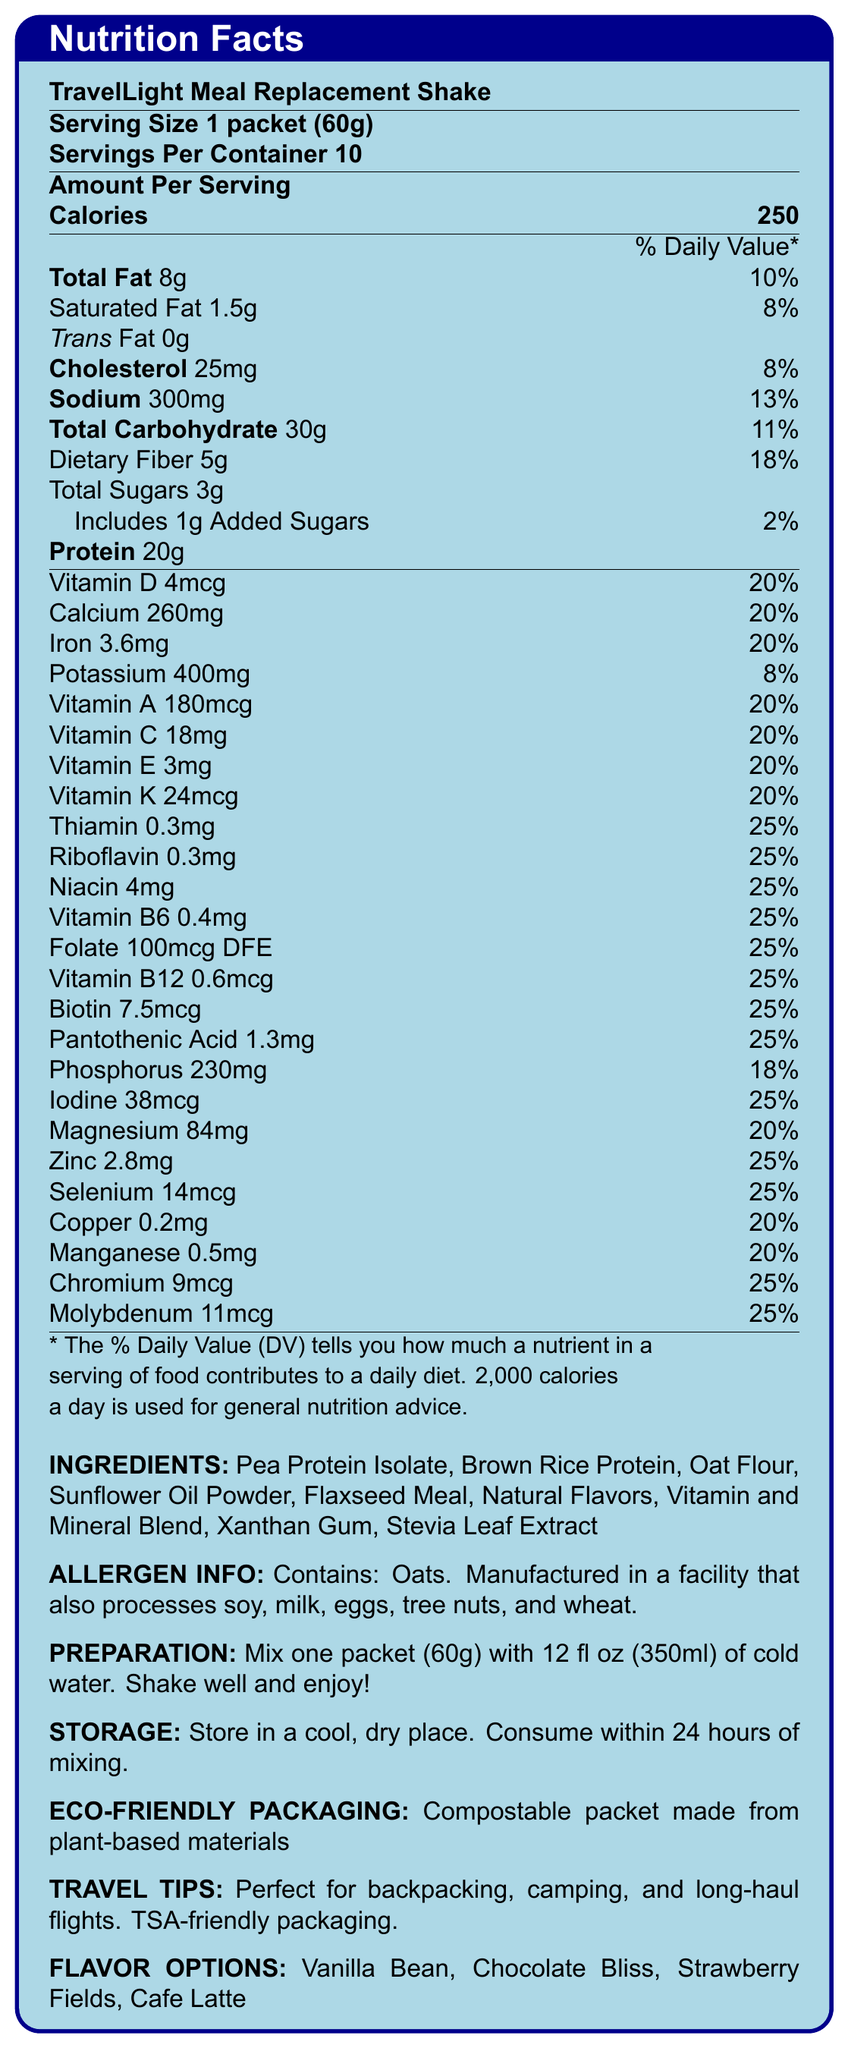What is the serving size of the TravelLight Meal Replacement Shake? The document states, "Serving Size 1 packet (60g)."
Answer: 1 packet (60g) How many calories does each packet of the meal replacement shake contain? The document specifies, "Calories 250."
Answer: 250 What is the total dietary fiber content per serving? The amount of dietary fiber per serving is listed as "Dietary Fiber 5g."
Answer: 5g Which vitamins and minerals provide 25% of the daily value? The document lists these vitamins and minerals with 25% daily value each.
Answer: Thiamin, Riboflavin, Niacin, Vitamin B6, Folate, Vitamin B12, Biotin, Pantothenic Acid, Iodine, Zinc, Selenium, Chromium, Molybdenum What are the preparation instructions for the TravelLight Meal Replacement Shake? The document provides the preparation instructions in the section labeled "PREPARATION."
Answer: Mix one packet (60g) with 12 fl oz (350ml) of cold water. Shake well and enjoy! What is the sodium content per serving? The sodium content per serving is listed as "Sodium 300mg."
Answer: 300mg What percentage of the daily value of total fat does one serving of the shake provide? A. 8% B. 10% C. 13% D. 20% The document states "Total Fat 8g" and "10%" daily value.
Answer: B Which of the following flavors is NOT mentioned as an option for the shake? A. Vanilla Bean B. Chocolate Bliss C. Strawberry Fields D. Mint Chocolate The listed flavors are Vanilla Bean, Chocolate Bliss, Strawberry Fields, and Cafe Latte.
Answer: D True or False: The meal replacement shake contains trans fat. The document specifies "Trans Fat 0g."
Answer: False Summarize the document's content in a few sentences. This summary captures the main points presented in the document.
Answer: The document provides a detailed breakdown of the nutrition facts for the TravelLight Meal Replacement Shake, including serving size, calories, various nutrients with their amounts and daily values, ingredients, allergen information, preparation and storage instructions, eco-friendly packaging details, and flavor options. It emphasizes that the shake is nutrient-dense and convenient for on-the-go travelers. What is the main source of protein in the TravelLight Meal Replacement Shake? The document lists multiple ingredients, including Pea Protein Isolate and Brown Rice Protein, but it does not specify which one is the main source.
Answer: Cannot be determined Does the TravelLight Meal Replacement Shake contain any added sugars? The document lists "Includes 1g Added Sugars" under the total sugars section.
Answer: Yes How many servings are there in a container of the shake? The document states "Servings Per Container 10."
Answer: 10 Can this product be taken on airplanes given the TSA guidelines? The document mentions "TSA-friendly packaging" under the "TRAVEL TIPS" section.
Answer: Yes Is the packaging of the TravelLight Meal Replacement Shake environmentally friendly? The document states "Compostable packet made from plant-based materials" under the "ECO-FRIENDLY PACKAGING" section.
Answer: Yes Which nutrient provides the highest percentage of the daily value per serving and what is its percentage? The document lists these nutrients each providing 25% of the daily value, the highest percentages shown.
Answer: Thiamin, Riboflavin, Niacin, Vitamin B6, Folate, Vitamin B12, Biotin, Pantothenic Acid, Iodine, Zinc, Selenium, Chromium, Molybdenum, 25% What allergens does the TravelLight Meal Replacement Shake contain? The document states "Contains: Oats" in the allergen information section.
Answer: Oats What should you do if you prepare the shake but don't consume it immediately? The document states "Consume within 24 hours of mixing" in the storage instructions.
Answer: Consume within 24 hours 